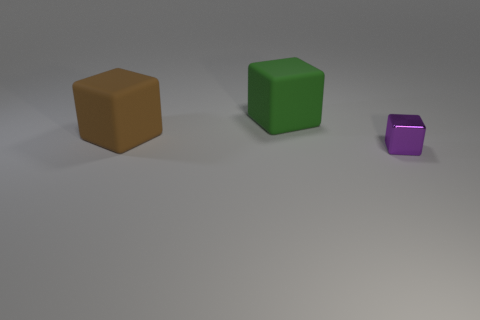Are there any other things that have the same material as the purple thing?
Your answer should be very brief. No. The purple metallic object that is the same shape as the green matte object is what size?
Keep it short and to the point. Small. Are there more tiny purple metal blocks that are in front of the big green matte thing than tiny metallic blocks?
Provide a succinct answer. No. Are the green object that is right of the brown matte thing and the tiny cube made of the same material?
Keep it short and to the point. No. What is the size of the matte block that is in front of the big block behind the thing to the left of the green thing?
Your response must be concise. Large. The thing that is both behind the small metal thing and to the right of the brown thing is what color?
Your response must be concise. Green. Does the big thing that is in front of the large green matte cube have the same shape as the large object right of the large brown cube?
Make the answer very short. Yes. What is the material of the cube behind the brown thing?
Provide a short and direct response. Rubber. What number of objects are either things that are to the left of the purple shiny object or purple metal objects?
Offer a very short reply. 3. Are there an equal number of big green objects right of the small block and small purple spheres?
Ensure brevity in your answer.  Yes. 